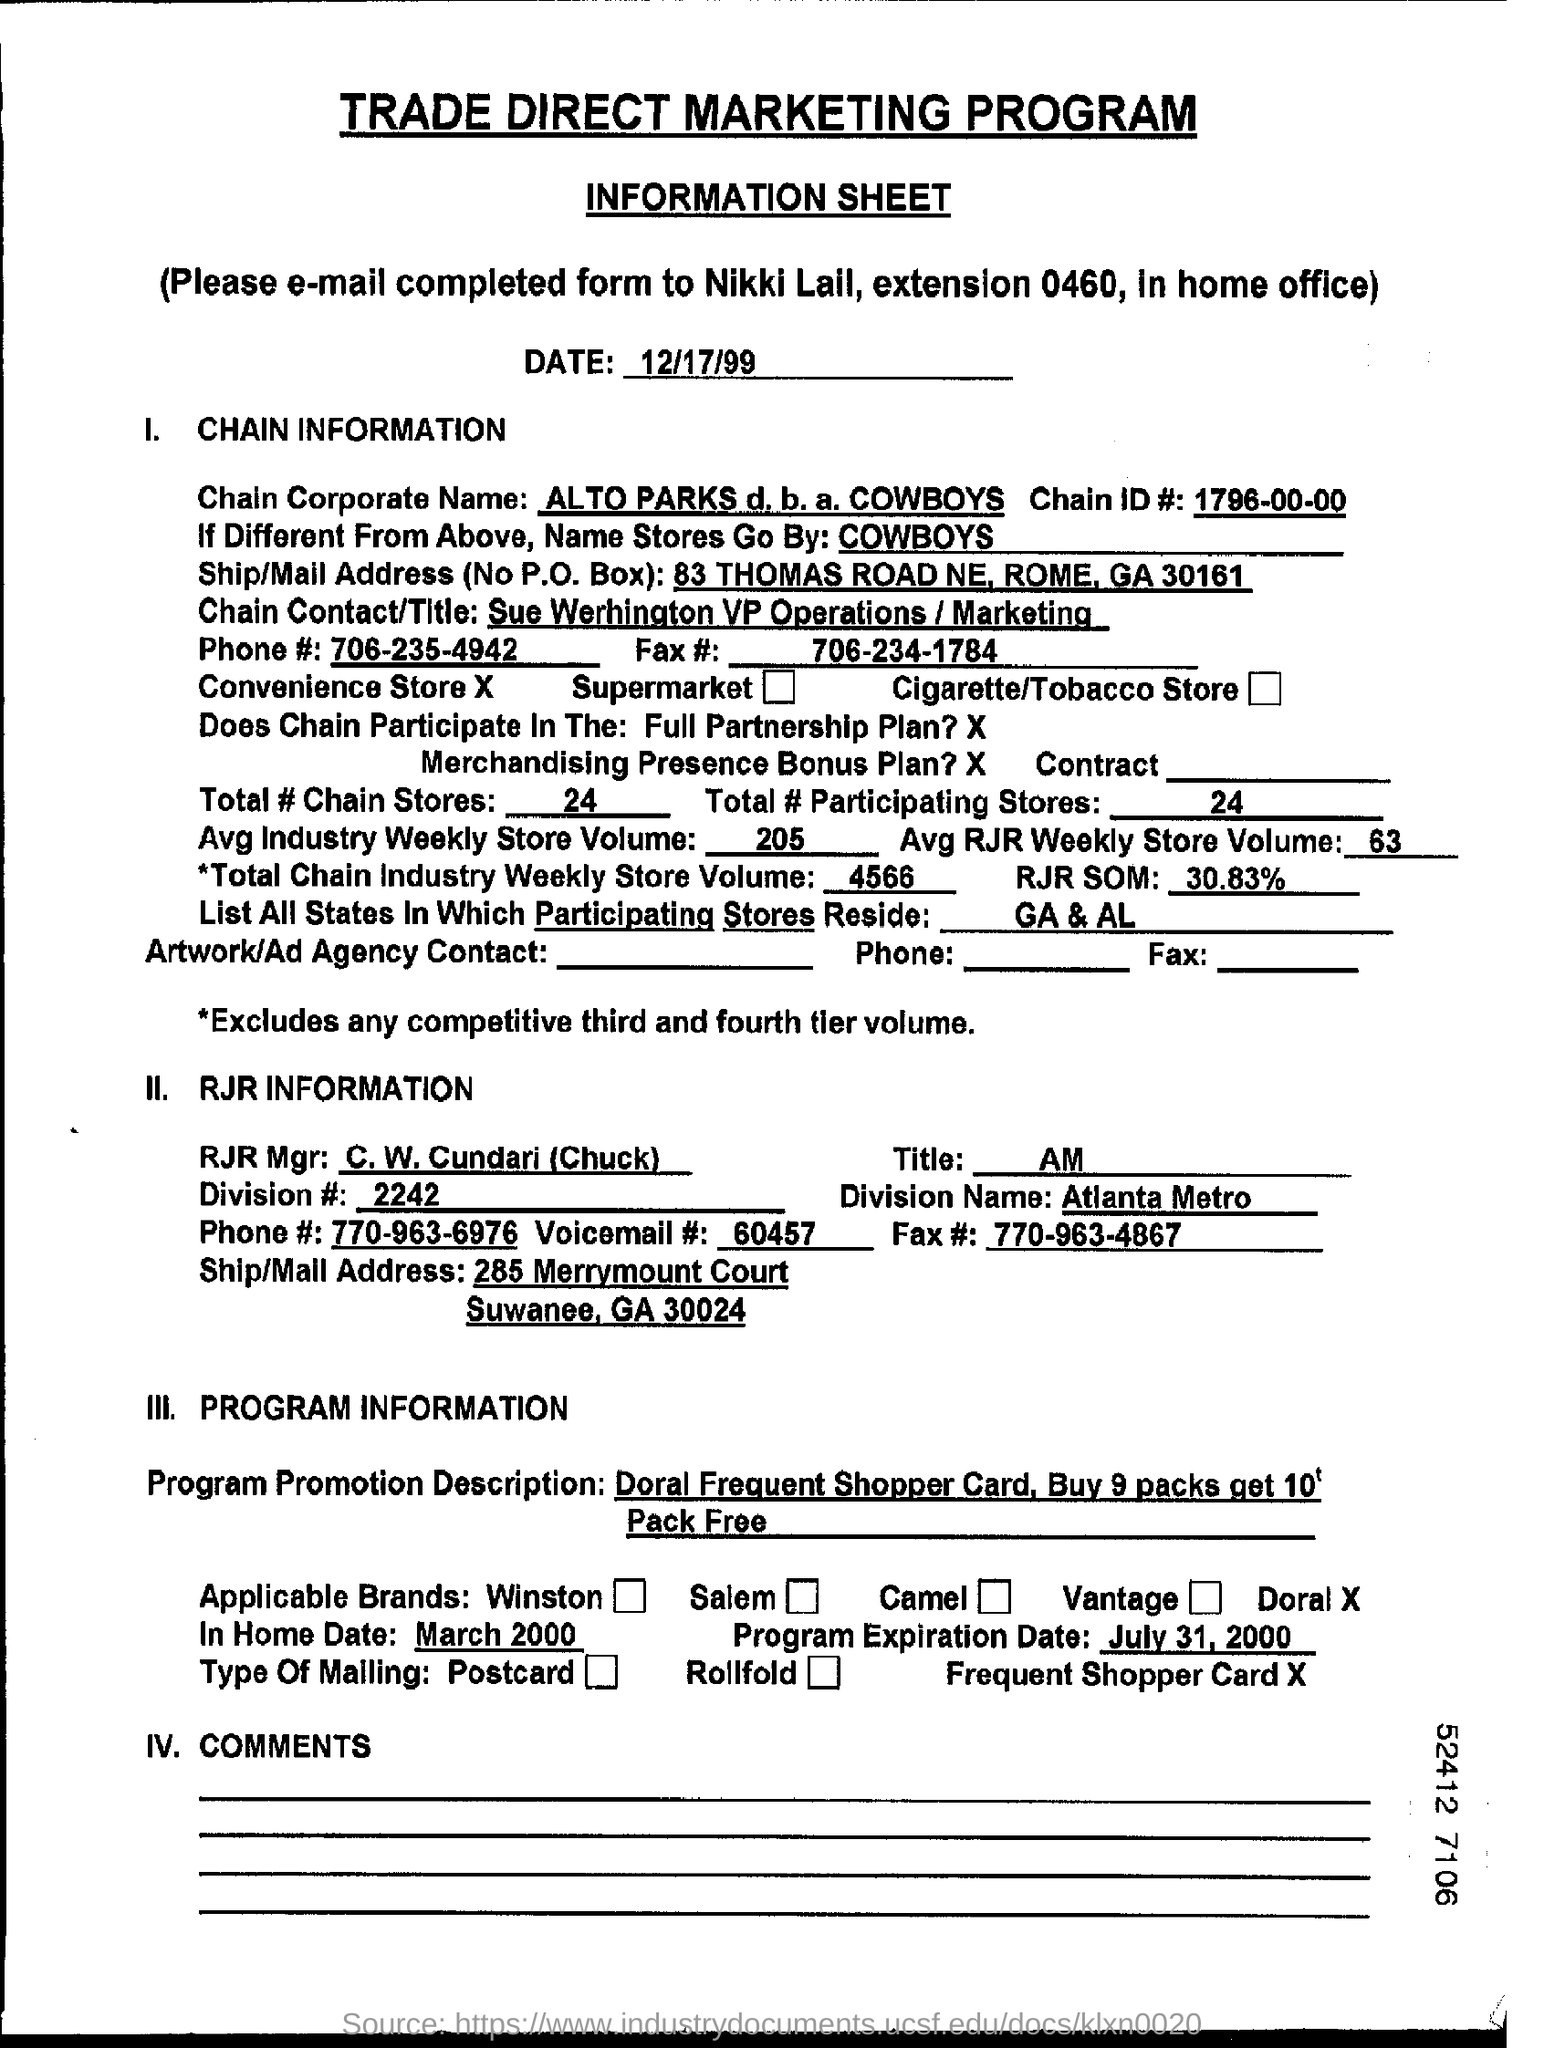Mention a couple of crucial points in this snapshot. The fax number is 706-234-1784. The total number of chain stores is 24. The program expiration date is July 31, 2000. The Chain ID number is 1796-00-00. The date on the document is December 17, 1999. 